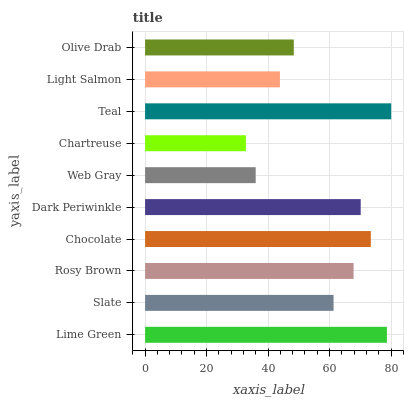Is Chartreuse the minimum?
Answer yes or no. Yes. Is Teal the maximum?
Answer yes or no. Yes. Is Slate the minimum?
Answer yes or no. No. Is Slate the maximum?
Answer yes or no. No. Is Lime Green greater than Slate?
Answer yes or no. Yes. Is Slate less than Lime Green?
Answer yes or no. Yes. Is Slate greater than Lime Green?
Answer yes or no. No. Is Lime Green less than Slate?
Answer yes or no. No. Is Rosy Brown the high median?
Answer yes or no. Yes. Is Slate the low median?
Answer yes or no. Yes. Is Dark Periwinkle the high median?
Answer yes or no. No. Is Lime Green the low median?
Answer yes or no. No. 